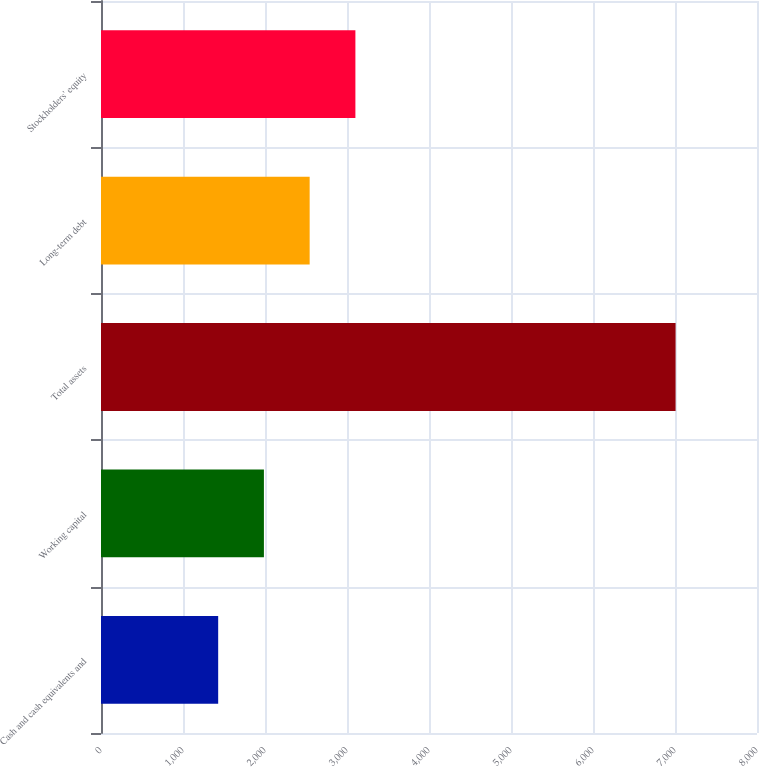Convert chart. <chart><loc_0><loc_0><loc_500><loc_500><bar_chart><fcel>Cash and cash equivalents and<fcel>Working capital<fcel>Total assets<fcel>Long-term debt<fcel>Stockholders' equity<nl><fcel>1429<fcel>1986.8<fcel>7007<fcel>2544.6<fcel>3102.4<nl></chart> 